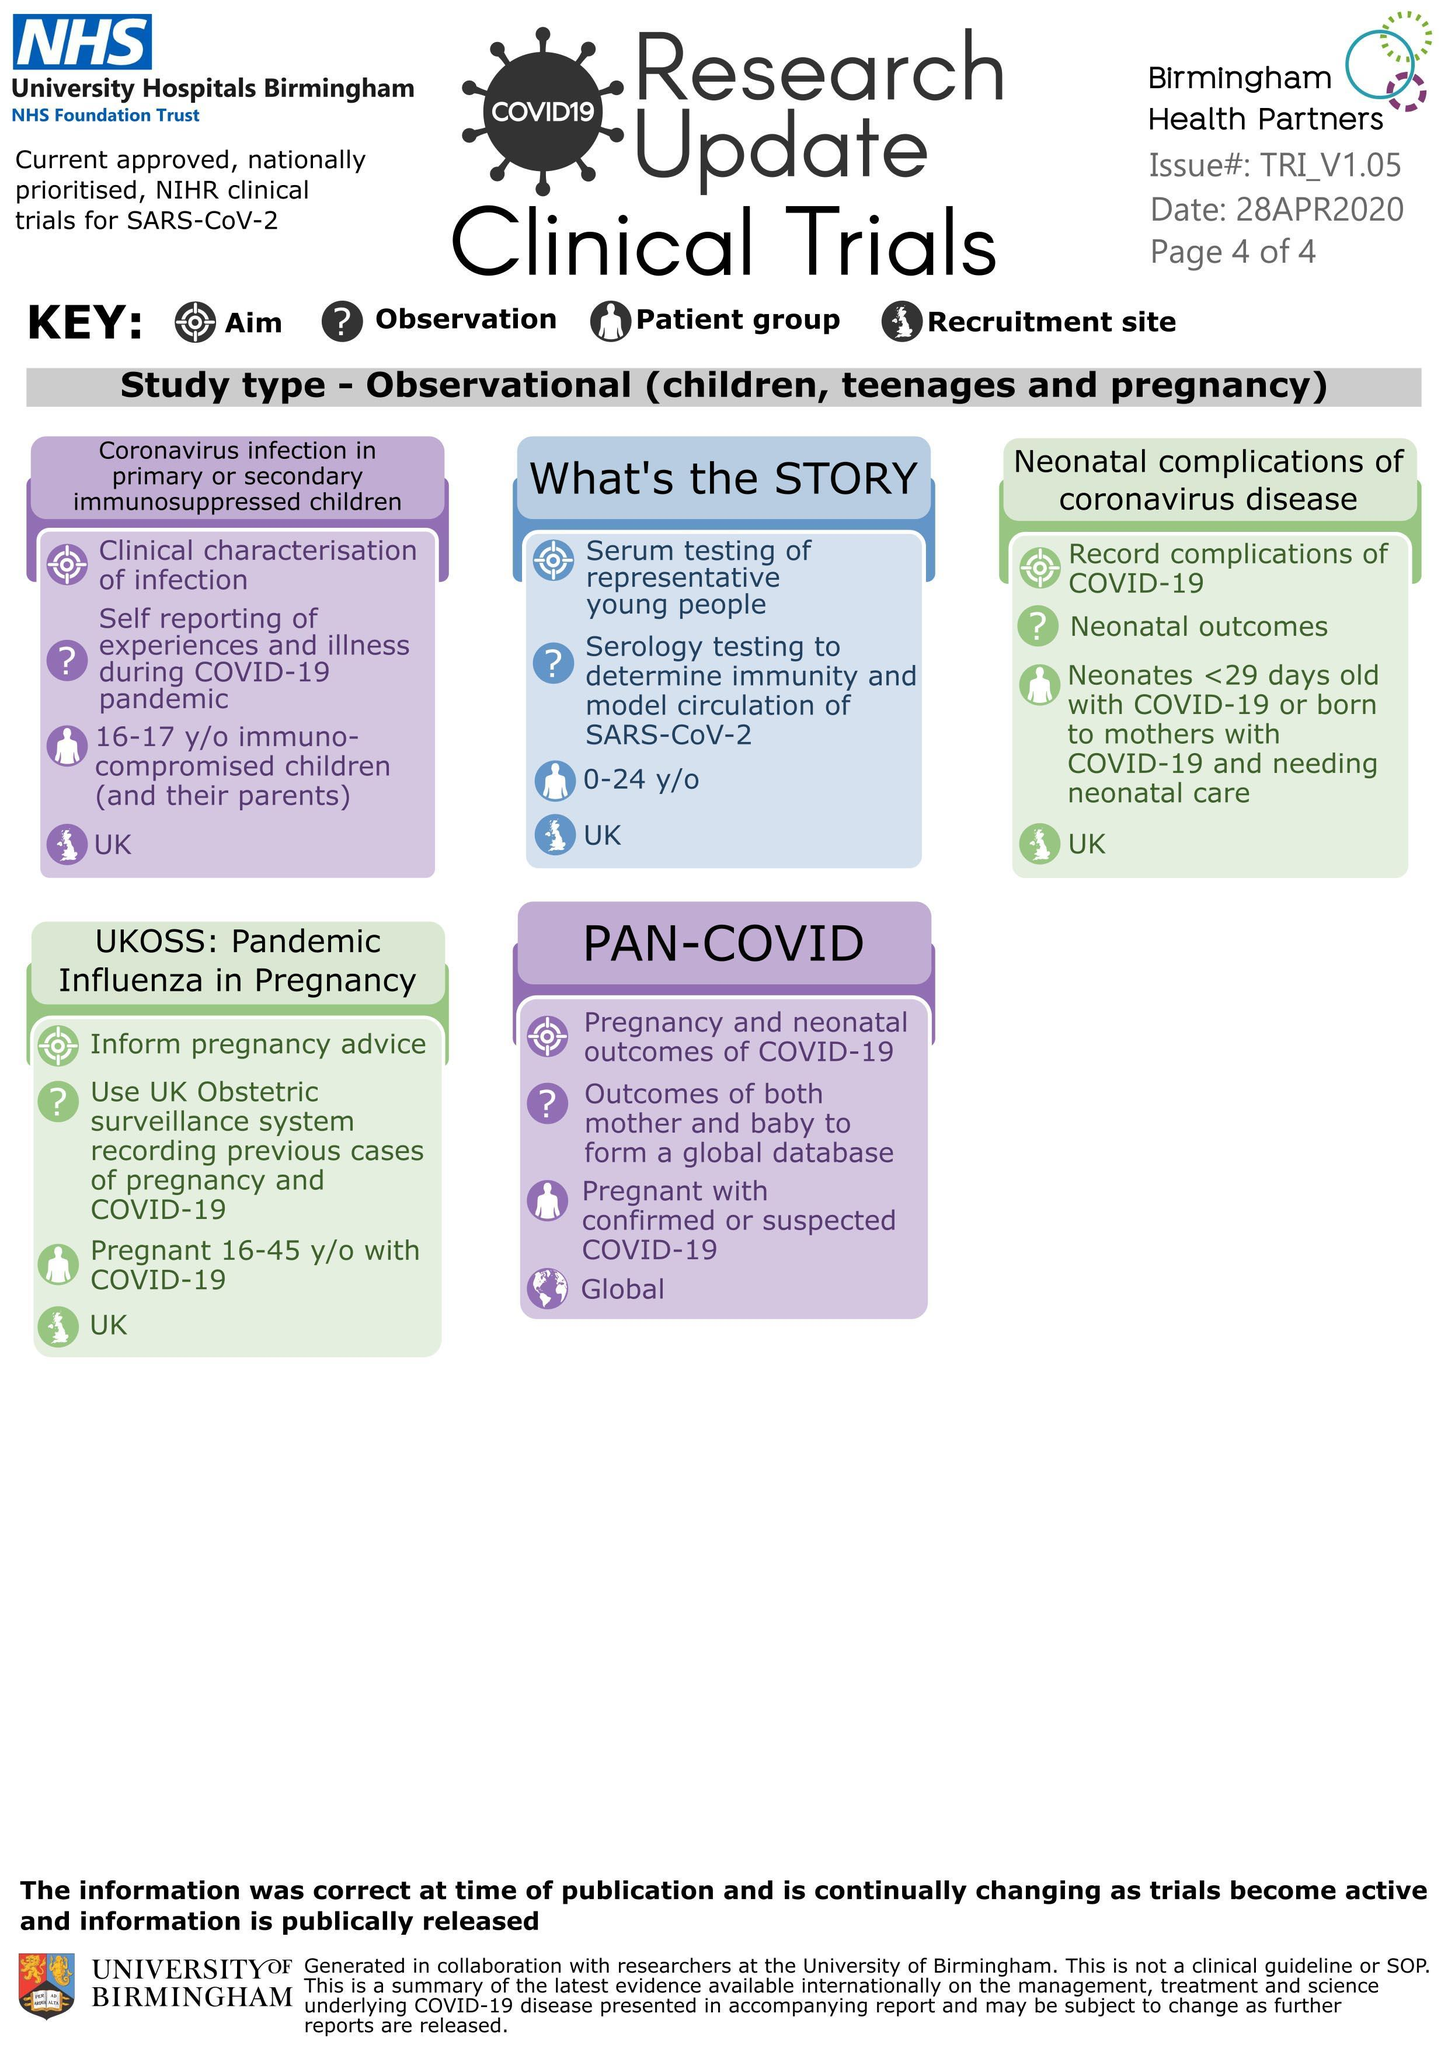How many 'keys' are given here?
Answer the question with a short phrase. 4 Which clinical trial has a global recruitment site? Pan-covid What is the aim of UKOSS : Pandemic influenza in pregnancy? Inform pregnancy advice What observations are made for the Pan-Covid clinical trial? Outcomes of both mother and baby to form a global database What is the patient group for Pan-Covid? Pregnant with confirmed or suspected COVID-19 What is the patient group for the clinical trial - 'what's the story'? 0-24 y/o How many clinical trials are recorded here? 5 Which trial has a patient group of 16 to 17 year old immuno-compromised children? Coronavirus infection in primary or secondary immunosuppressed children What is the aim of the Pan-Covid trial? Pregnancy and neonatal outcomes of COVID-19 In the second clinical trial what does 'STORY' stand for? Serum testing of representative young people What is the aim of 'What's The Story'? Serum testing of representative young people What is a restriction site of the first four clinical trials mentioned year? UK 